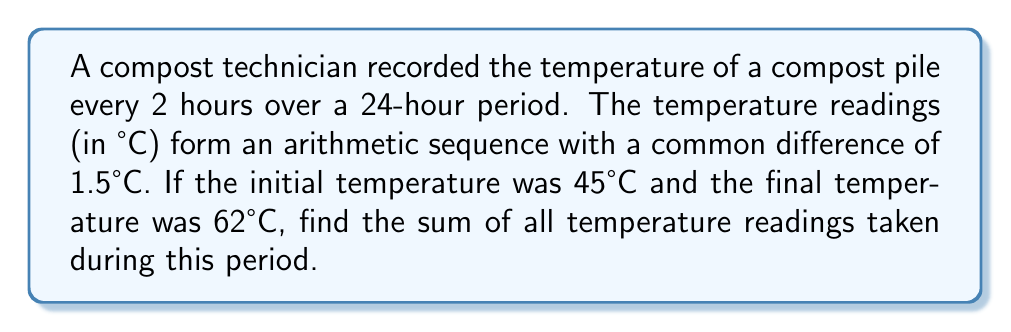Teach me how to tackle this problem. Let's approach this step-by-step:

1) First, we need to determine how many temperature readings were taken:
   - The period is 24 hours
   - Readings are taken every 2 hours
   - Number of readings = $24 \div 2 + 1 = 13$ (including the initial and final readings)

2) We're told this is an arithmetic sequence. Let's recall the formula for the sum of an arithmetic sequence:
   $$S_n = \frac{n}{2}(a_1 + a_n)$$
   Where $S_n$ is the sum, $n$ is the number of terms, $a_1$ is the first term, and $a_n$ is the last term.

3) We know:
   - $n = 13$
   - $a_1 = 45°C$
   - $a_{13} = 62°C$

4) Plugging these into our formula:
   $$S_{13} = \frac{13}{2}(45 + 62)$$

5) Simplifying:
   $$S_{13} = \frac{13}{2}(107) = 13 \times 53.5 = 695.5$$

Therefore, the sum of all temperature readings is 695.5°C.
Answer: 695.5°C 